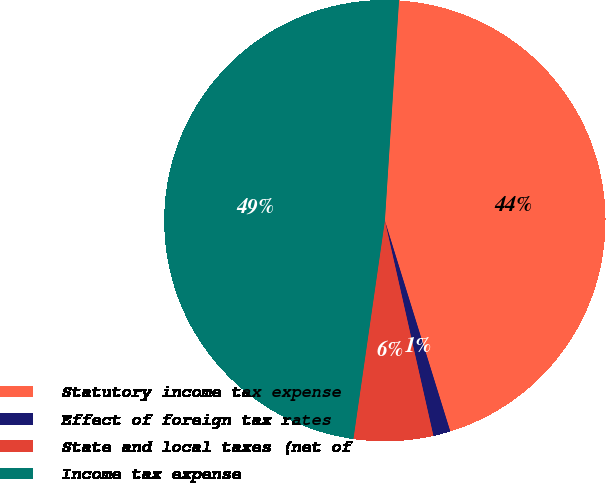Convert chart to OTSL. <chart><loc_0><loc_0><loc_500><loc_500><pie_chart><fcel>Statutory income tax expense<fcel>Effect of foreign tax rates<fcel>State and local taxes (net of<fcel>Income tax expense<nl><fcel>44.19%<fcel>1.26%<fcel>5.81%<fcel>48.74%<nl></chart> 